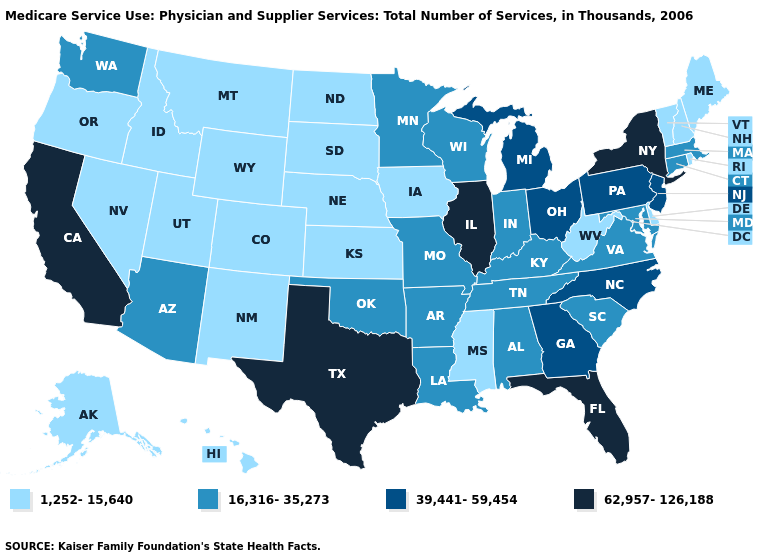Does Montana have the highest value in the West?
Answer briefly. No. Does Vermont have the same value as Hawaii?
Be succinct. Yes. What is the lowest value in the South?
Keep it brief. 1,252-15,640. Among the states that border Louisiana , does Mississippi have the highest value?
Write a very short answer. No. Name the states that have a value in the range 16,316-35,273?
Short answer required. Alabama, Arizona, Arkansas, Connecticut, Indiana, Kentucky, Louisiana, Maryland, Massachusetts, Minnesota, Missouri, Oklahoma, South Carolina, Tennessee, Virginia, Washington, Wisconsin. Which states have the lowest value in the West?
Write a very short answer. Alaska, Colorado, Hawaii, Idaho, Montana, Nevada, New Mexico, Oregon, Utah, Wyoming. What is the value of Connecticut?
Keep it brief. 16,316-35,273. Does West Virginia have a higher value than Kansas?
Keep it brief. No. Which states hav the highest value in the West?
Be succinct. California. Among the states that border Illinois , does Iowa have the highest value?
Write a very short answer. No. What is the value of South Carolina?
Be succinct. 16,316-35,273. Among the states that border Delaware , which have the highest value?
Write a very short answer. New Jersey, Pennsylvania. Which states hav the highest value in the Northeast?
Answer briefly. New York. 